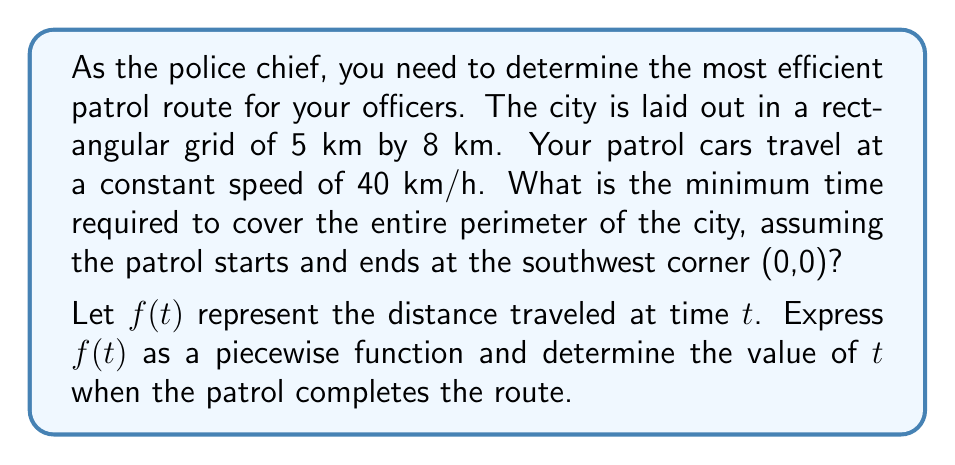Could you help me with this problem? To solve this problem, we'll follow these steps:

1) First, let's calculate the perimeter of the city:
   $2(5 \text{ km} + 8 \text{ km}) = 26 \text{ km}$

2) Now, we need to express the distance traveled as a function of time. The patrol car moves at a constant speed of 40 km/h, so we can use the equation: distance = rate * time

3) We'll create a piecewise function for $f(t)$ based on which side of the rectangle the patrol car is on:

   $$f(t) = \begin{cases}
   40t & 0 \leq t < 0.125 \\
   5 + 40(t - 0.125) & 0.125 \leq t < 0.325 \\
   13 + 40(t - 0.325) & 0.325 \leq t < 0.45 \\
   18 + 40(t - 0.45) & 0.45 \leq t \leq 0.65
   \end{cases}$$

   Where:
   - 0 to 0.125 hours (5 km): East side
   - 0.125 to 0.325 hours (8 km): North side
   - 0.325 to 0.45 hours (5 km): West side
   - 0.45 to 0.65 hours (8 km): South side

4) To find when the patrol completes the route, we need to solve:
   $f(t) = 26$

5) Using the last piece of the function:
   $18 + 40(t - 0.45) = 26$
   $40(t - 0.45) = 8$
   $t - 0.45 = 0.2$
   $t = 0.65$

6) Convert to minutes:
   $0.65 \text{ hours} * 60 \text{ minutes/hour} = 39 \text{ minutes}$
Answer: 39 minutes 